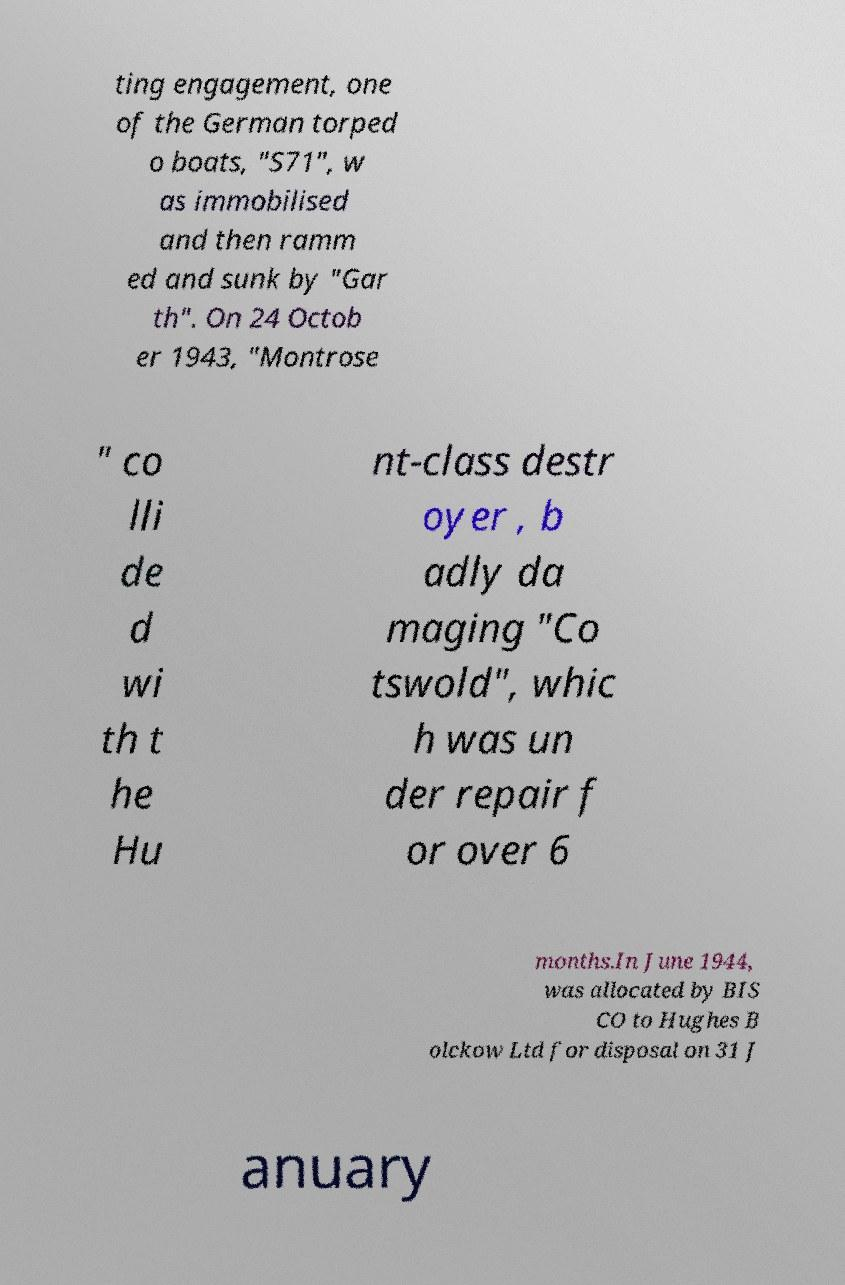Could you extract and type out the text from this image? ting engagement, one of the German torped o boats, "S71", w as immobilised and then ramm ed and sunk by "Gar th". On 24 Octob er 1943, "Montrose " co lli de d wi th t he Hu nt-class destr oyer , b adly da maging "Co tswold", whic h was un der repair f or over 6 months.In June 1944, was allocated by BIS CO to Hughes B olckow Ltd for disposal on 31 J anuary 